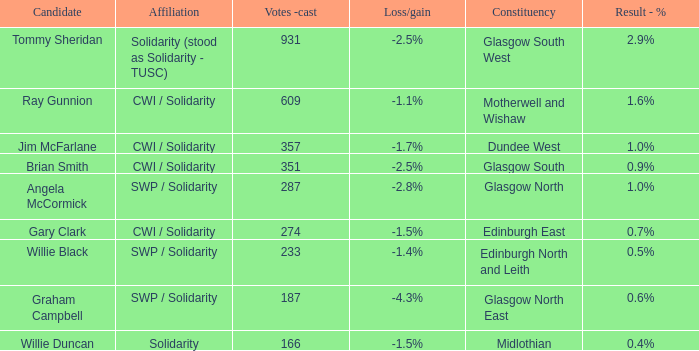Who was the candidate when the result - % was 0.4%? Willie Duncan. 